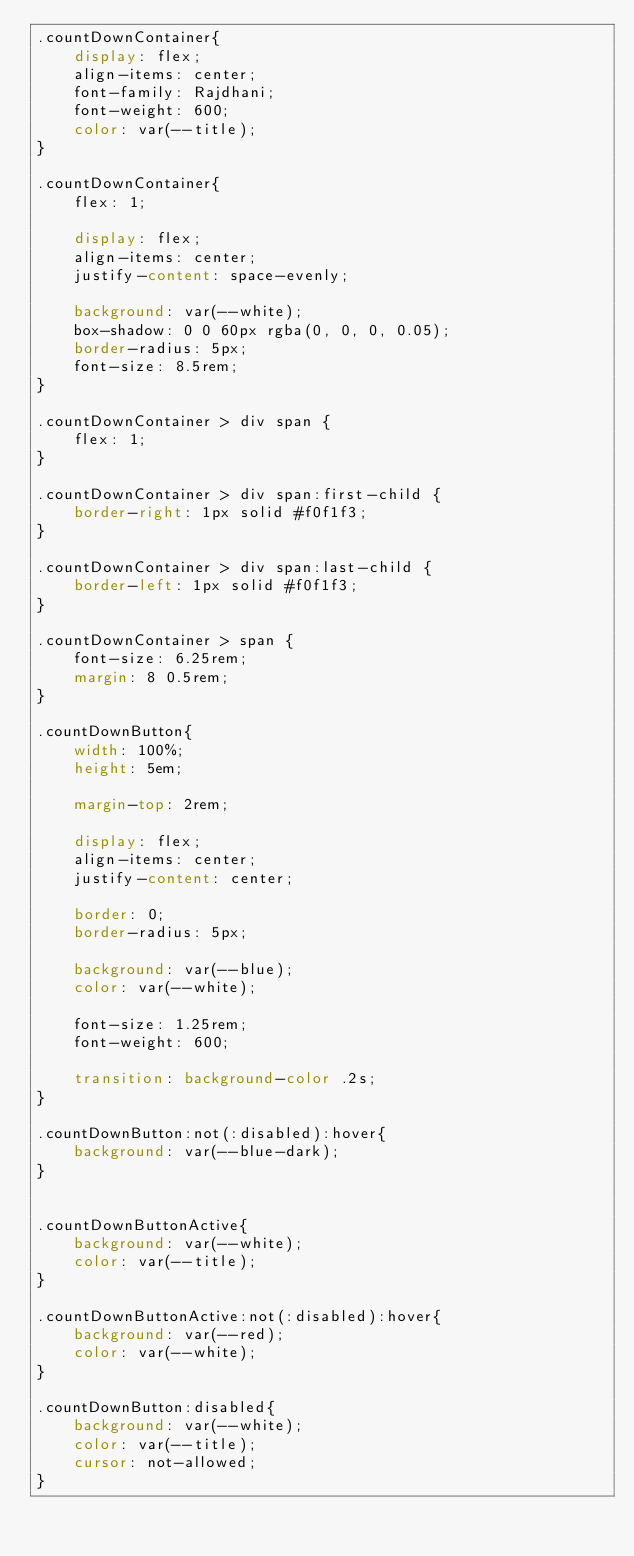Convert code to text. <code><loc_0><loc_0><loc_500><loc_500><_CSS_>.countDownContainer{
    display: flex;
    align-items: center;
    font-family: Rajdhani;
    font-weight: 600;
    color: var(--title);
}

.countDownContainer{
    flex: 1;

    display: flex;
    align-items: center;
    justify-content: space-evenly;

    background: var(--white);
    box-shadow: 0 0 60px rgba(0, 0, 0, 0.05);
    border-radius: 5px;
    font-size: 8.5rem;
}

.countDownContainer > div span {
    flex: 1;
}

.countDownContainer > div span:first-child {
    border-right: 1px solid #f0f1f3;
}

.countDownContainer > div span:last-child {
    border-left: 1px solid #f0f1f3;
}

.countDownContainer > span {
    font-size: 6.25rem;
    margin: 8 0.5rem;
}

.countDownButton{
    width: 100%;
    height: 5em;
    
    margin-top: 2rem;

    display: flex;
    align-items: center;
    justify-content: center;

    border: 0;
    border-radius: 5px;
    
    background: var(--blue);
    color: var(--white);

    font-size: 1.25rem;
    font-weight: 600;

    transition: background-color .2s;
}

.countDownButton:not(:disabled):hover{
    background: var(--blue-dark);
}


.countDownButtonActive{
    background: var(--white);
    color: var(--title);
}

.countDownButtonActive:not(:disabled):hover{
    background: var(--red);
    color: var(--white);
}

.countDownButton:disabled{
    background: var(--white);
    color: var(--title);
    cursor: not-allowed;
}</code> 